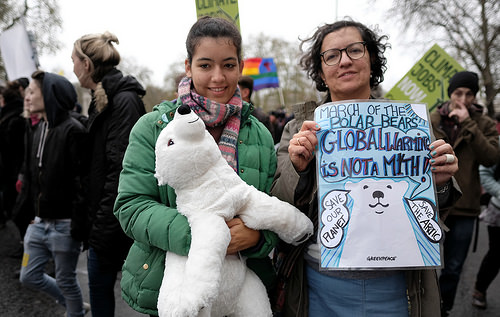<image>
Is the bear next to the scarf? Yes. The bear is positioned adjacent to the scarf, located nearby in the same general area. 